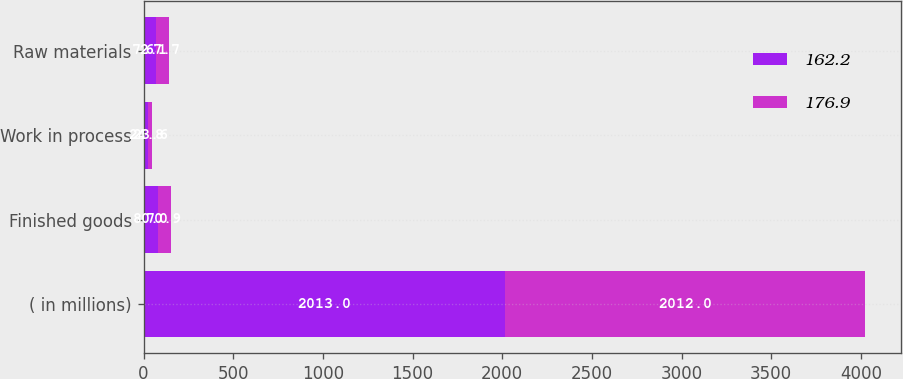Convert chart to OTSL. <chart><loc_0><loc_0><loc_500><loc_500><stacked_bar_chart><ecel><fcel>( in millions)<fcel>Finished goods<fcel>Work in process<fcel>Raw materials<nl><fcel>162.2<fcel>2013<fcel>80<fcel>24.8<fcel>72.1<nl><fcel>176.9<fcel>2012<fcel>70.9<fcel>23.6<fcel>67.7<nl></chart> 